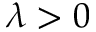Convert formula to latex. <formula><loc_0><loc_0><loc_500><loc_500>\lambda > 0</formula> 